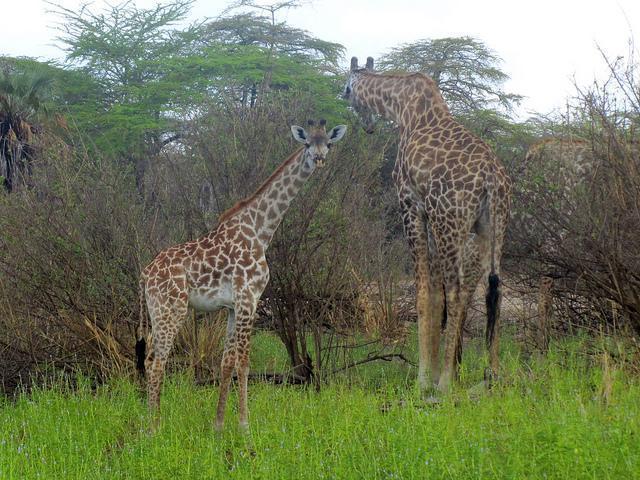How many giraffes are looking toward the camera?
Give a very brief answer. 1. How many animals are in this photo?
Give a very brief answer. 2. How many giraffes are there?
Give a very brief answer. 2. How many giraffe's are there?
Give a very brief answer. 2. How many giraffes are in the picture?
Give a very brief answer. 2. 